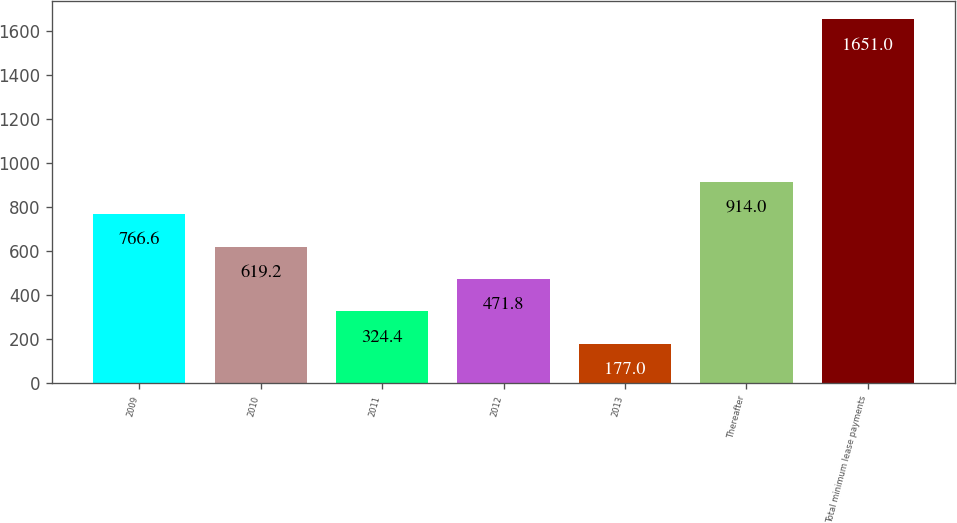<chart> <loc_0><loc_0><loc_500><loc_500><bar_chart><fcel>2009<fcel>2010<fcel>2011<fcel>2012<fcel>2013<fcel>Thereafter<fcel>Total minimum lease payments<nl><fcel>766.6<fcel>619.2<fcel>324.4<fcel>471.8<fcel>177<fcel>914<fcel>1651<nl></chart> 